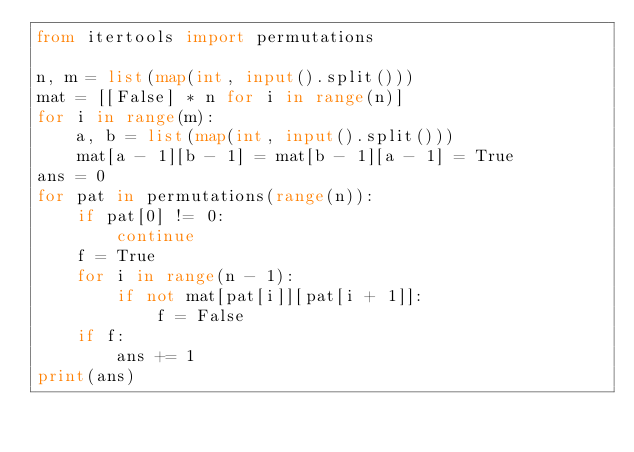<code> <loc_0><loc_0><loc_500><loc_500><_Python_>from itertools import permutations

n, m = list(map(int, input().split()))
mat = [[False] * n for i in range(n)]
for i in range(m):
    a, b = list(map(int, input().split()))
    mat[a - 1][b - 1] = mat[b - 1][a - 1] = True
ans = 0
for pat in permutations(range(n)):
    if pat[0] != 0:
        continue
    f = True
    for i in range(n - 1):
        if not mat[pat[i]][pat[i + 1]]:
            f = False
    if f:
        ans += 1
print(ans)</code> 